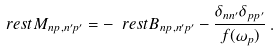Convert formula to latex. <formula><loc_0><loc_0><loc_500><loc_500>\ r e s t { M } _ { n p , n ^ { \prime } p ^ { \prime } } = - \ r e s t { B } _ { n p , n ^ { \prime } p ^ { \prime } } - \frac { \delta _ { n n ^ { \prime } } \delta _ { p p ^ { \prime } } } { f ( \omega _ { p } ) } \, .</formula> 